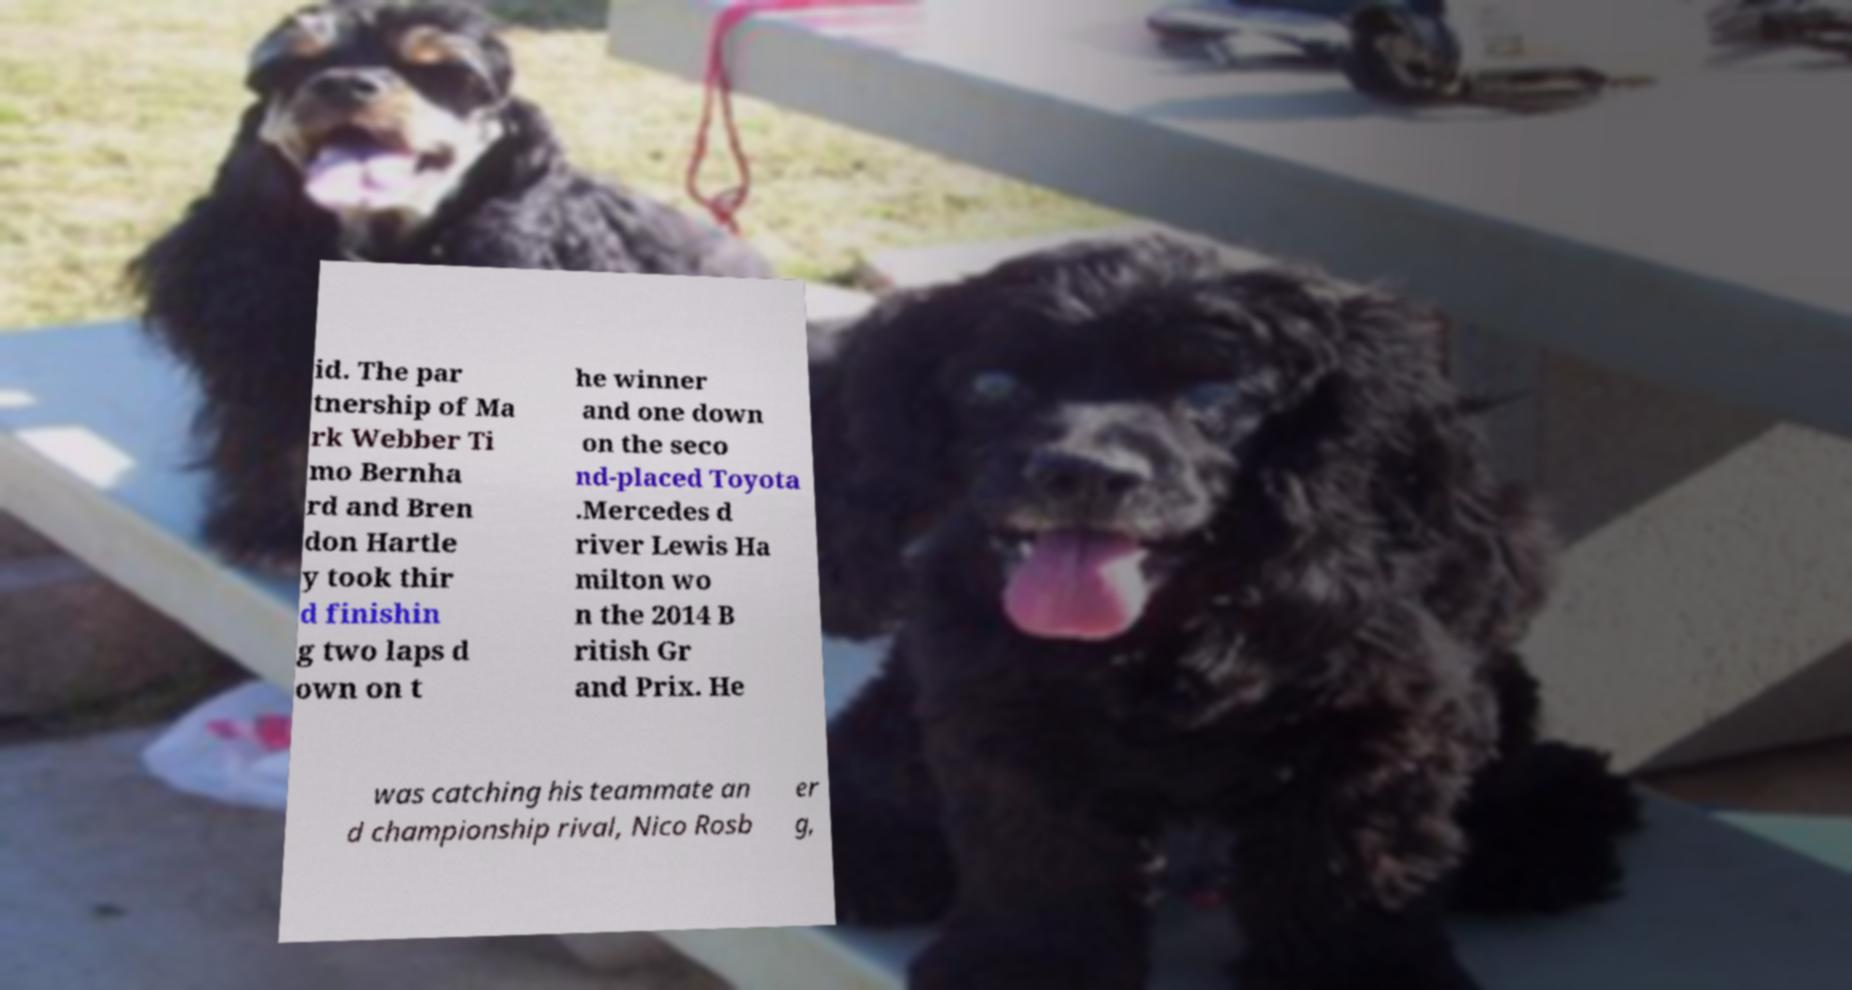Can you accurately transcribe the text from the provided image for me? id. The par tnership of Ma rk Webber Ti mo Bernha rd and Bren don Hartle y took thir d finishin g two laps d own on t he winner and one down on the seco nd-placed Toyota .Mercedes d river Lewis Ha milton wo n the 2014 B ritish Gr and Prix. He was catching his teammate an d championship rival, Nico Rosb er g, 